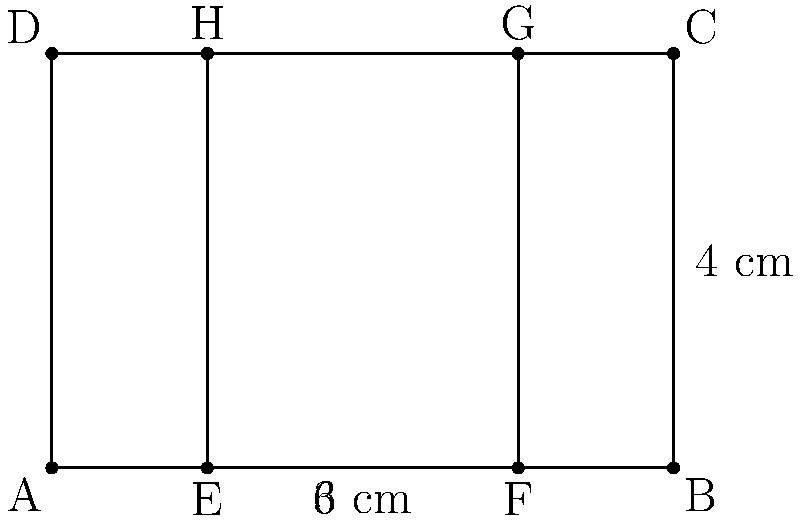You're designing a symmetrical body kit for a luxury car. The base shape of the kit is a rectangle ABCD, measuring 6 cm wide and 4 cm tall. Inside this, you want to create a smaller rectangular cutout EFGH, centered horizontally. If EF measures 3 cm, what is the area of the remaining body kit material (the shaded region)? Let's solve this step-by-step:

1) First, let's calculate the area of the entire body kit (rectangle ABCD):
   Area of ABCD = $6 \text{ cm} \times 4 \text{ cm} = 24 \text{ cm}^2$

2) Now, we need to find the dimensions of the cutout EFGH:
   - We know EF is 3 cm
   - The cutout is centered horizontally, so the space on each side is equal:
     $(6 \text{ cm} - 3 \text{ cm}) \div 2 = 1.5 \text{ cm}$
   - The height of the cutout is the same as the main rectangle, 4 cm

3) Calculate the area of the cutout EFGH:
   Area of EFGH = $3 \text{ cm} \times 4 \text{ cm} = 12 \text{ cm}^2$

4) The area of the remaining body kit material is the difference between these areas:
   Remaining area = Area of ABCD - Area of EFGH
                  = $24 \text{ cm}^2 - 12 \text{ cm}^2 = 12 \text{ cm}^2$
Answer: $12 \text{ cm}^2$ 